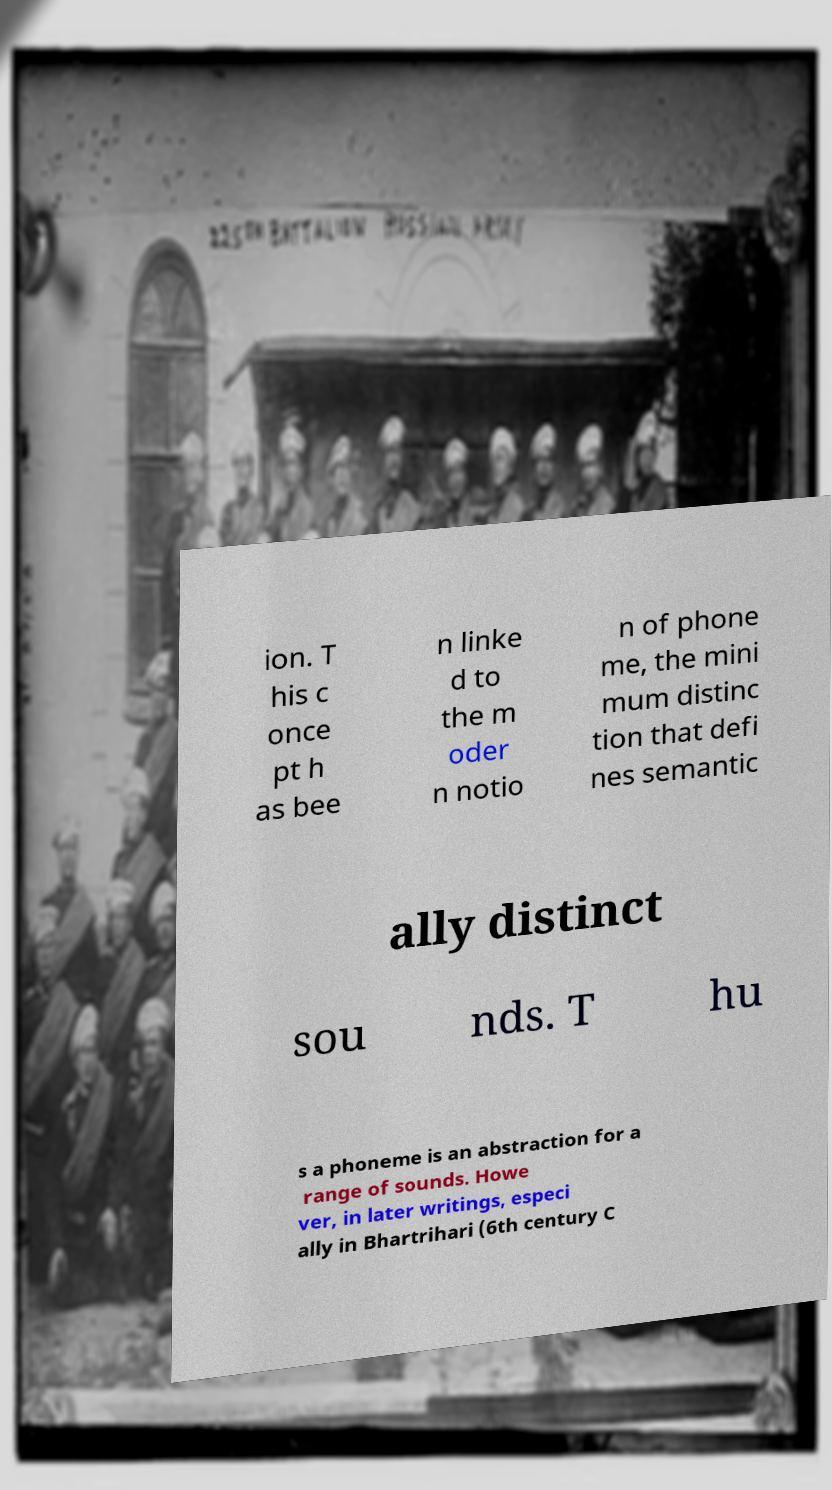There's text embedded in this image that I need extracted. Can you transcribe it verbatim? ion. T his c once pt h as bee n linke d to the m oder n notio n of phone me, the mini mum distinc tion that defi nes semantic ally distinct sou nds. T hu s a phoneme is an abstraction for a range of sounds. Howe ver, in later writings, especi ally in Bhartrihari (6th century C 